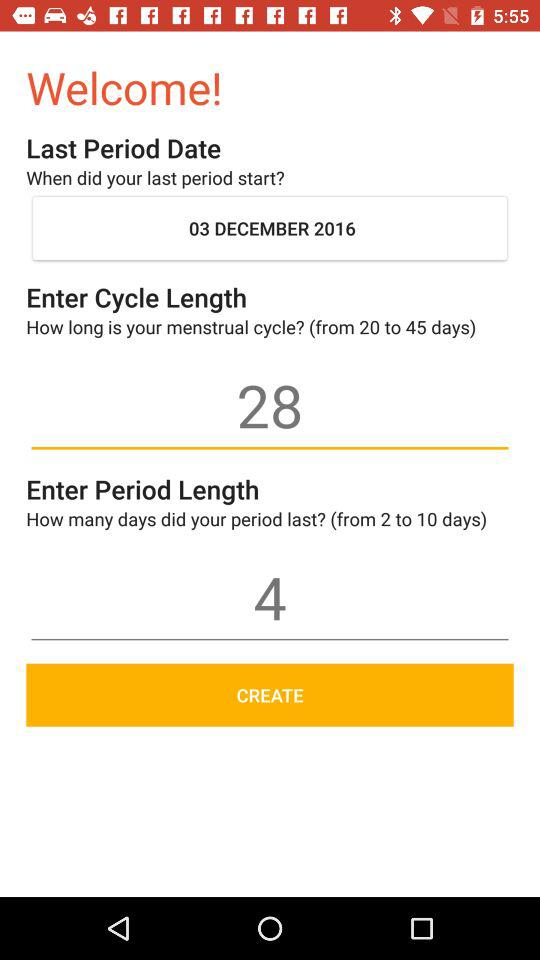What is the length of the cycle? The length of the cycle is 28 days. 